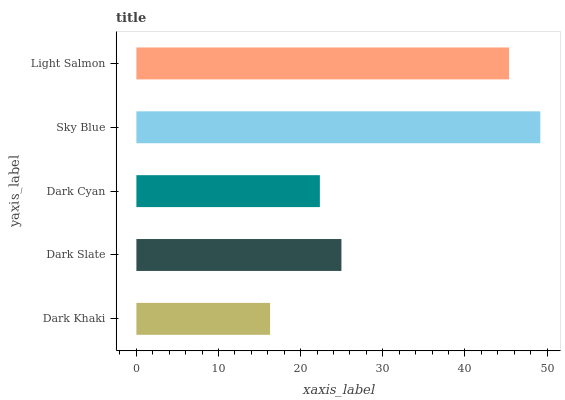Is Dark Khaki the minimum?
Answer yes or no. Yes. Is Sky Blue the maximum?
Answer yes or no. Yes. Is Dark Slate the minimum?
Answer yes or no. No. Is Dark Slate the maximum?
Answer yes or no. No. Is Dark Slate greater than Dark Khaki?
Answer yes or no. Yes. Is Dark Khaki less than Dark Slate?
Answer yes or no. Yes. Is Dark Khaki greater than Dark Slate?
Answer yes or no. No. Is Dark Slate less than Dark Khaki?
Answer yes or no. No. Is Dark Slate the high median?
Answer yes or no. Yes. Is Dark Slate the low median?
Answer yes or no. Yes. Is Dark Cyan the high median?
Answer yes or no. No. Is Dark Khaki the low median?
Answer yes or no. No. 